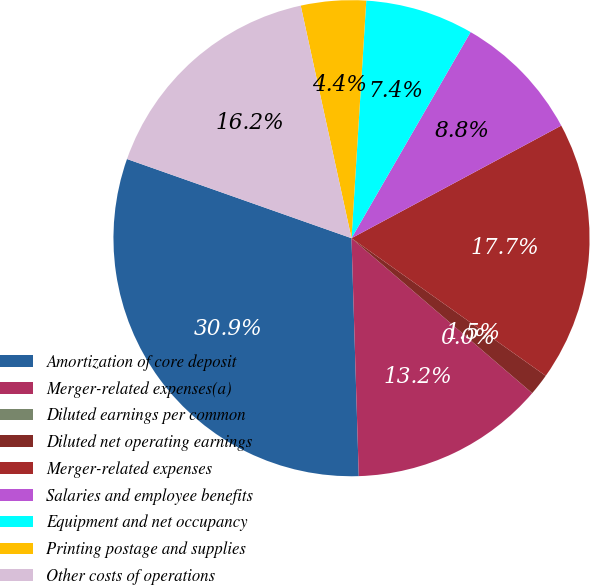<chart> <loc_0><loc_0><loc_500><loc_500><pie_chart><fcel>Amortization of core deposit<fcel>Merger-related expenses(a)<fcel>Diluted earnings per common<fcel>Diluted net operating earnings<fcel>Merger-related expenses<fcel>Salaries and employee benefits<fcel>Equipment and net occupancy<fcel>Printing postage and supplies<fcel>Other costs of operations<nl><fcel>30.88%<fcel>13.23%<fcel>0.0%<fcel>1.47%<fcel>17.65%<fcel>8.82%<fcel>7.35%<fcel>4.41%<fcel>16.18%<nl></chart> 